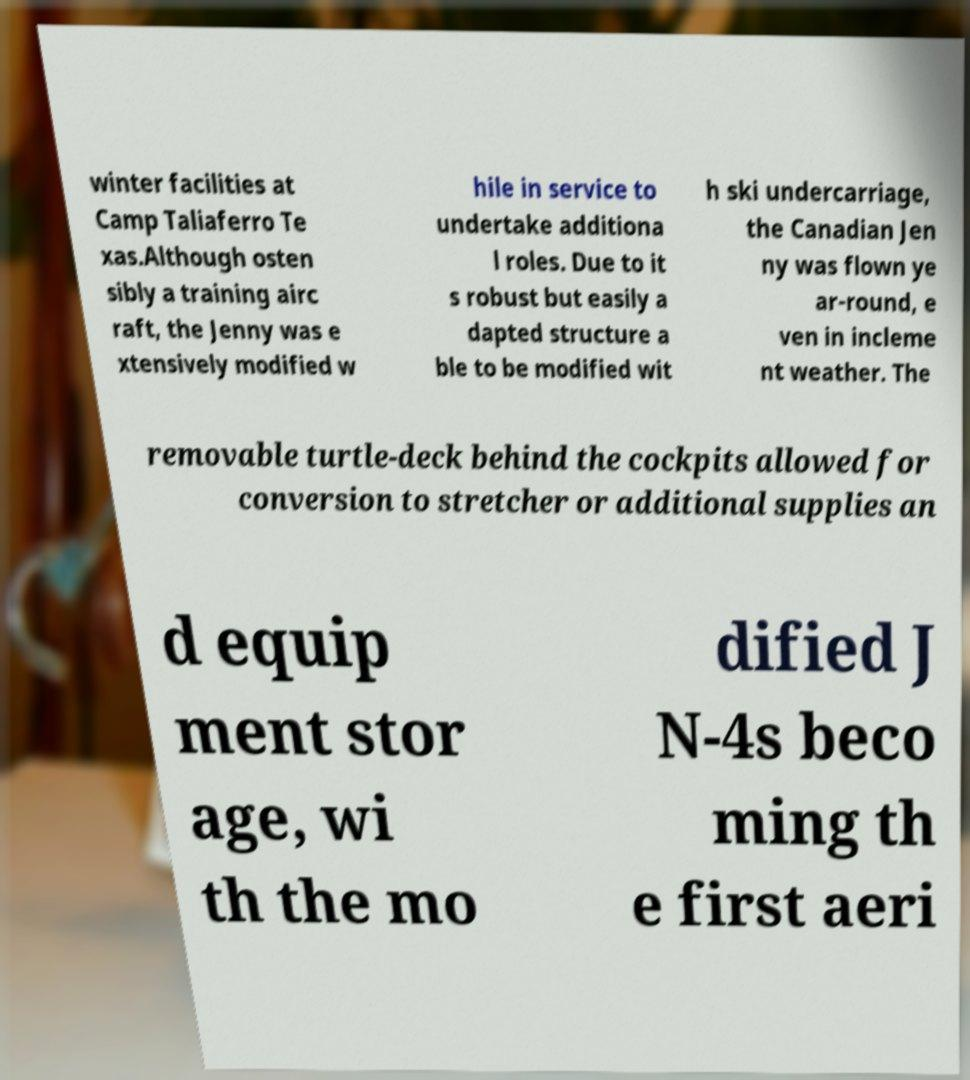Can you accurately transcribe the text from the provided image for me? winter facilities at Camp Taliaferro Te xas.Although osten sibly a training airc raft, the Jenny was e xtensively modified w hile in service to undertake additiona l roles. Due to it s robust but easily a dapted structure a ble to be modified wit h ski undercarriage, the Canadian Jen ny was flown ye ar-round, e ven in incleme nt weather. The removable turtle-deck behind the cockpits allowed for conversion to stretcher or additional supplies an d equip ment stor age, wi th the mo dified J N-4s beco ming th e first aeri 